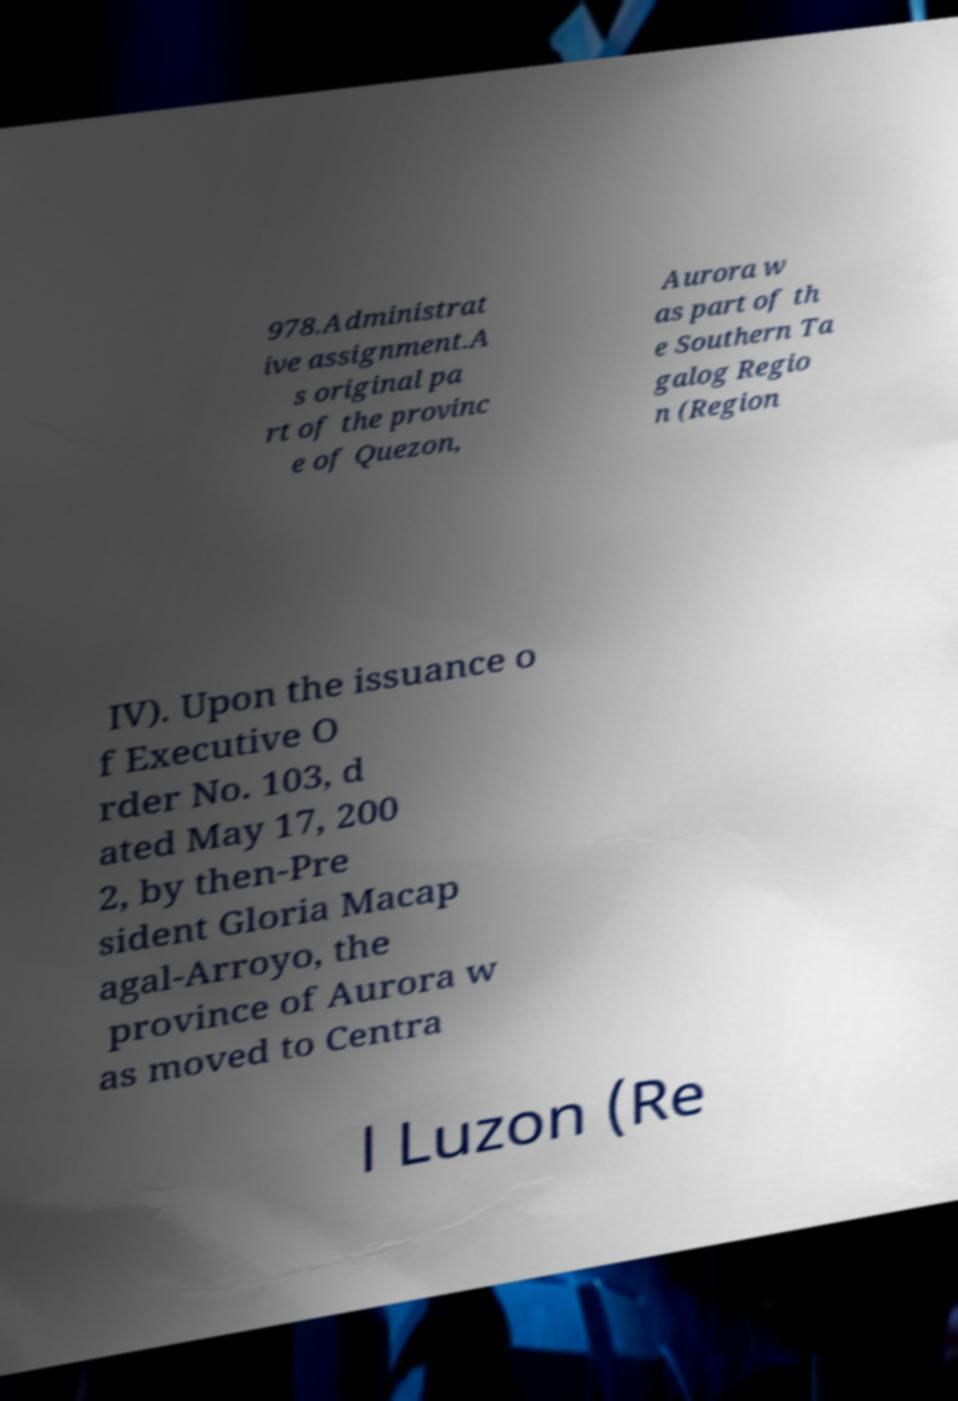I need the written content from this picture converted into text. Can you do that? 978.Administrat ive assignment.A s original pa rt of the provinc e of Quezon, Aurora w as part of th e Southern Ta galog Regio n (Region IV). Upon the issuance o f Executive O rder No. 103, d ated May 17, 200 2, by then-Pre sident Gloria Macap agal-Arroyo, the province of Aurora w as moved to Centra l Luzon (Re 